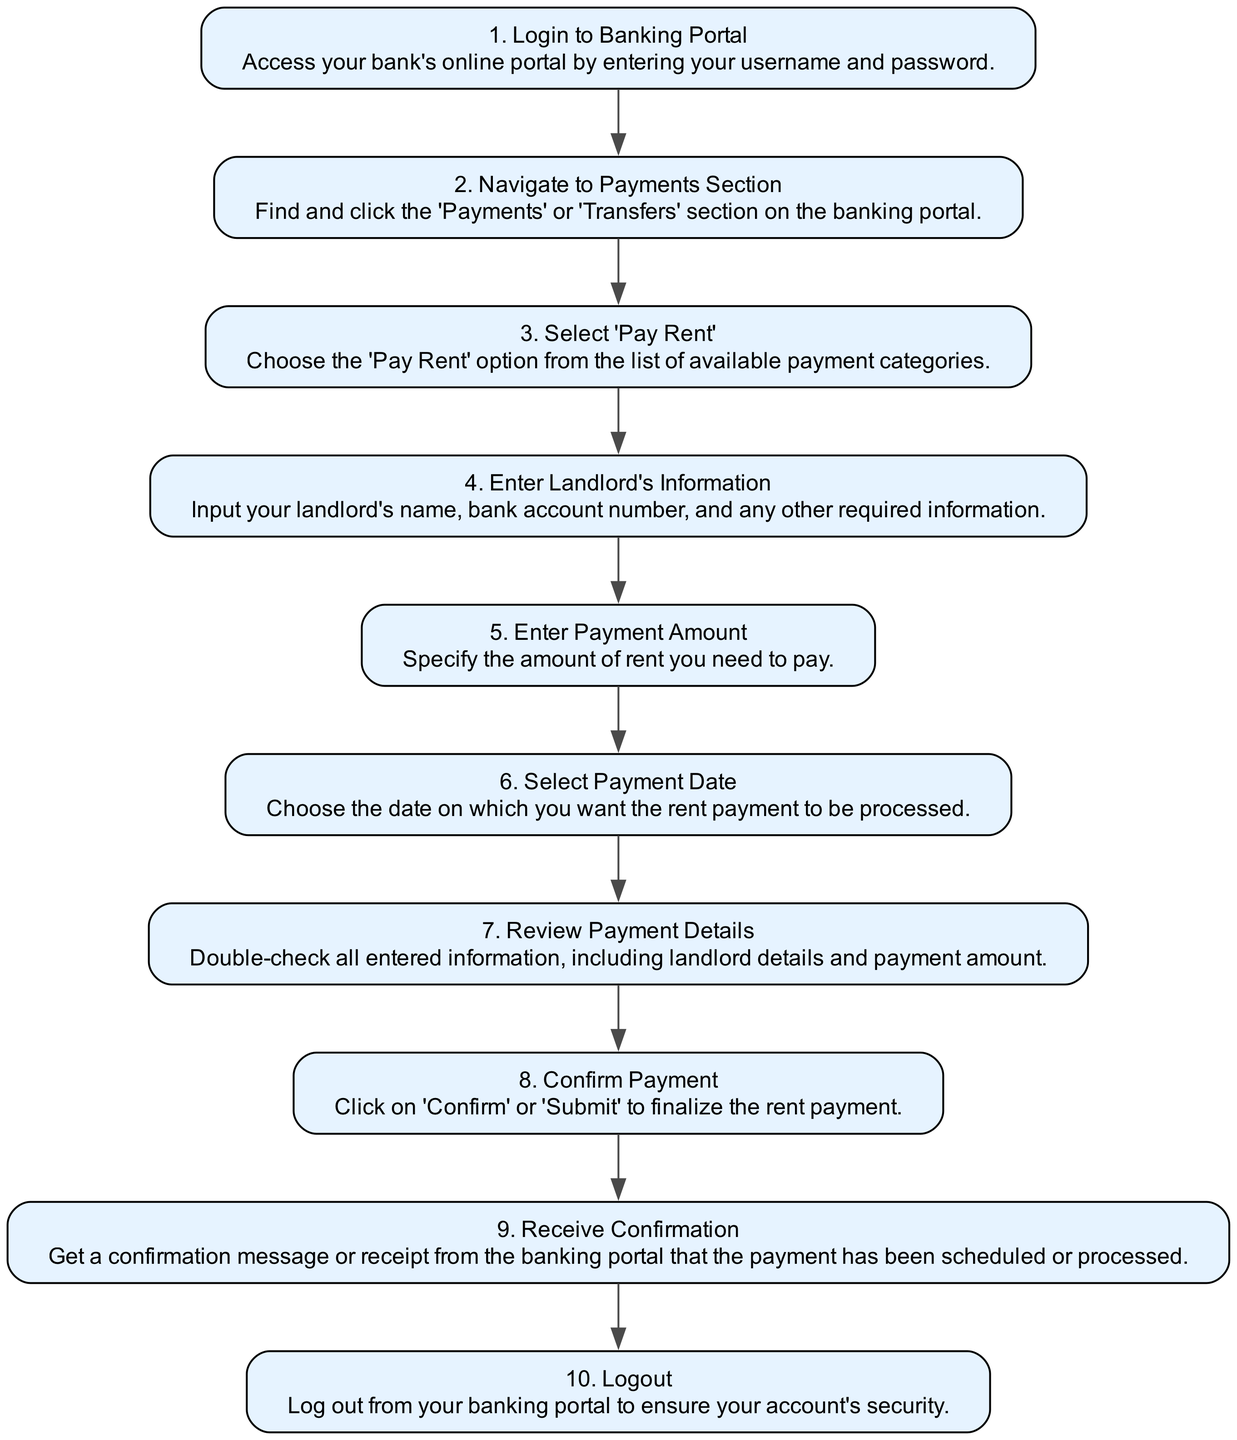What is the first step to pay rent online? The first step in the diagram is to "Login to Banking Portal," which requires entering your username and password to access the bank’s portal.
Answer: Login to Banking Portal How many nodes are in the diagram? Counting all the steps listed, there are 10 nodes representing each step in the rent payment process.
Answer: 10 What do you need to enter after selecting 'Pay Rent'? After selecting 'Pay Rent', you need to "Enter Landlord's Information" which includes details like the landlord's name and bank account number.
Answer: Enter Landlord's Information What message do you receive after confirming the payment? After confirming the payment, you will receive a "Receive Confirmation" message or receipt indicating the payment has been processed.
Answer: Receive Confirmation Which step comes immediately before confirming the payment? The step immediately before confirming the payment is "Review Payment Details," where you double-check all entered information.
Answer: Review Payment Details What information is required at the point of entering payment amount? At the point of entering payment amount, you need to "Specify the amount of rent you need to pay."
Answer: Specify the amount of rent you need to pay What action is taken after receiving confirmation? After receiving confirmation, the next action is to "Logout" from your banking portal to ensure account security.
Answer: Logout How many payment-related sections are mentioned in the diagram? The diagram specifically mentions three payment-related sections: Navigate to Payments Section, Select 'Pay Rent', and Confirm Payment.
Answer: Three Which step involves checking details before finalization? The step that involves checking details before finalization is "Review Payment Details." You must ensure all information is correct prior to submission.
Answer: Review Payment Details What is the final step in the rent payment process? The final step in the rent payment process is to "Logout," ensuring that your banking portal account remains secure after use.
Answer: Logout 